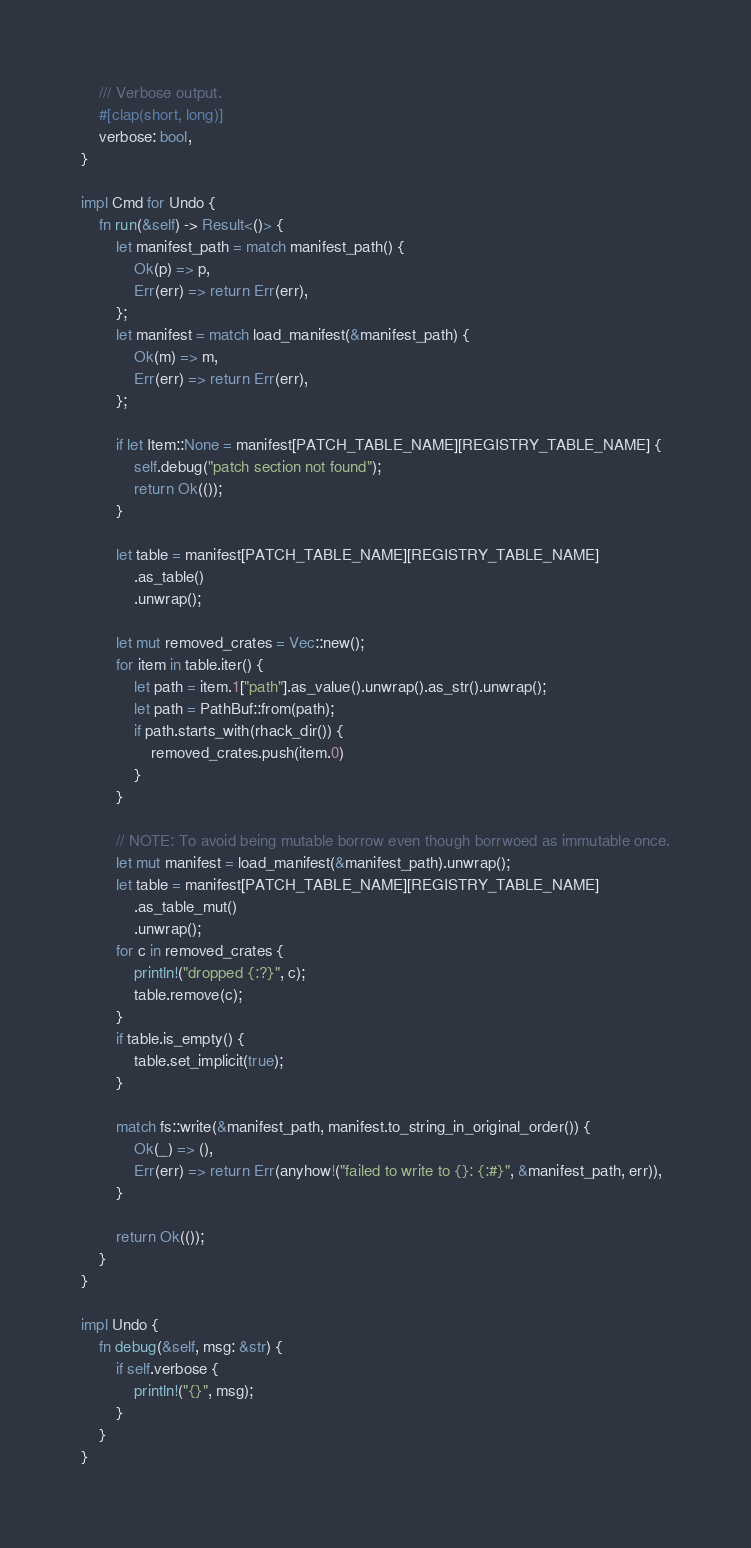<code> <loc_0><loc_0><loc_500><loc_500><_Rust_>    /// Verbose output.
    #[clap(short, long)]
    verbose: bool,
}

impl Cmd for Undo {
    fn run(&self) -> Result<()> {
        let manifest_path = match manifest_path() {
            Ok(p) => p,
            Err(err) => return Err(err),
        };
        let manifest = match load_manifest(&manifest_path) {
            Ok(m) => m,
            Err(err) => return Err(err),
        };

        if let Item::None = manifest[PATCH_TABLE_NAME][REGISTRY_TABLE_NAME] {
            self.debug("patch section not found");
            return Ok(());
        }

        let table = manifest[PATCH_TABLE_NAME][REGISTRY_TABLE_NAME]
            .as_table()
            .unwrap();

        let mut removed_crates = Vec::new();
        for item in table.iter() {
            let path = item.1["path"].as_value().unwrap().as_str().unwrap();
            let path = PathBuf::from(path);
            if path.starts_with(rhack_dir()) {
                removed_crates.push(item.0)
            }
        }

        // NOTE: To avoid being mutable borrow even though borrwoed as immutable once.
        let mut manifest = load_manifest(&manifest_path).unwrap();
        let table = manifest[PATCH_TABLE_NAME][REGISTRY_TABLE_NAME]
            .as_table_mut()
            .unwrap();
        for c in removed_crates {
            println!("dropped {:?}", c);
            table.remove(c);
        }
        if table.is_empty() {
            table.set_implicit(true);
        }

        match fs::write(&manifest_path, manifest.to_string_in_original_order()) {
            Ok(_) => (),
            Err(err) => return Err(anyhow!("failed to write to {}: {:#}", &manifest_path, err)),
        }

        return Ok(());
    }
}

impl Undo {
    fn debug(&self, msg: &str) {
        if self.verbose {
            println!("{}", msg);
        }
    }
}
</code> 